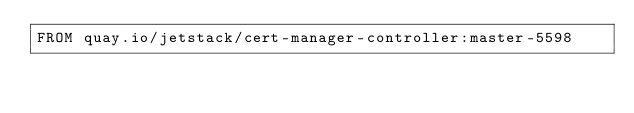<code> <loc_0><loc_0><loc_500><loc_500><_Dockerfile_>FROM quay.io/jetstack/cert-manager-controller:master-5598
</code> 